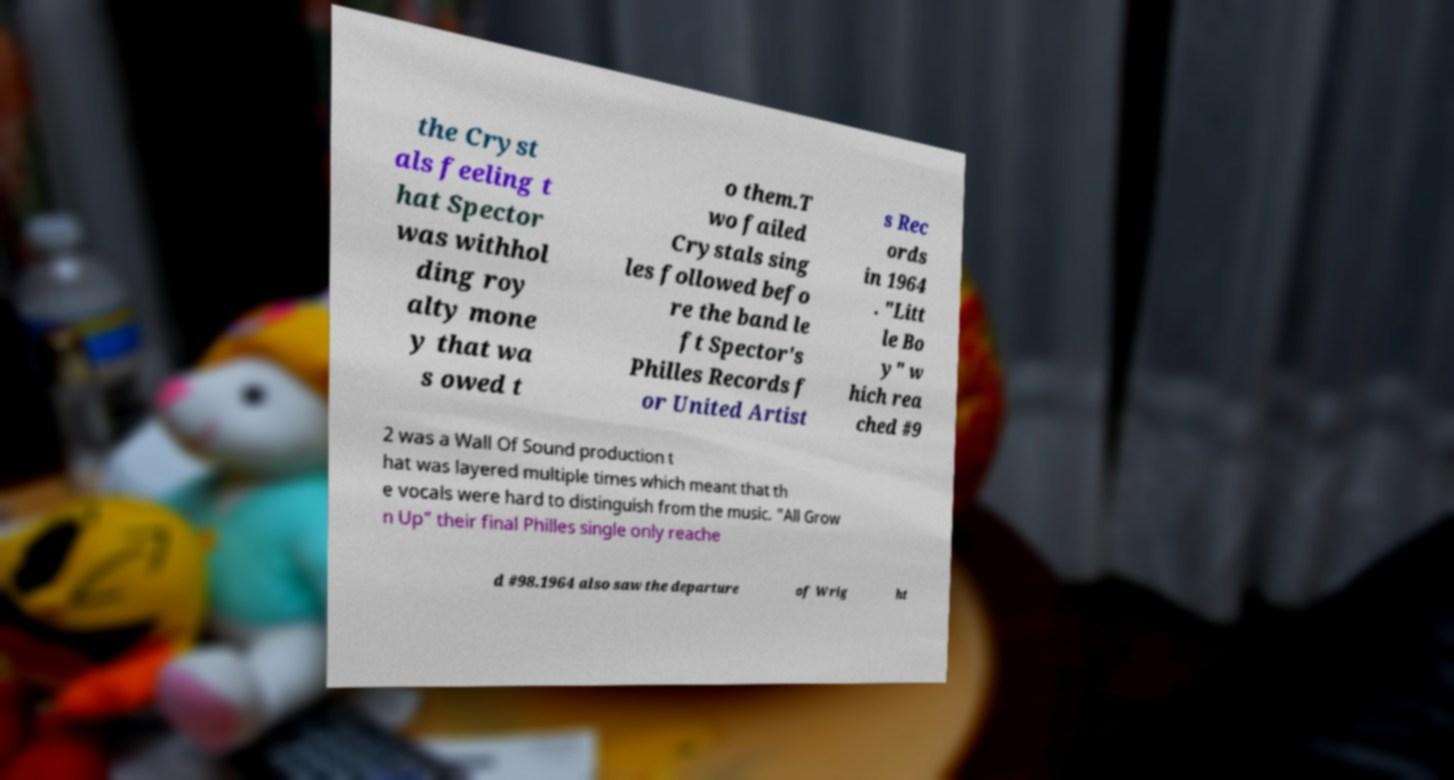Could you extract and type out the text from this image? the Cryst als feeling t hat Spector was withhol ding roy alty mone y that wa s owed t o them.T wo failed Crystals sing les followed befo re the band le ft Spector's Philles Records f or United Artist s Rec ords in 1964 . "Litt le Bo y" w hich rea ched #9 2 was a Wall Of Sound production t hat was layered multiple times which meant that th e vocals were hard to distinguish from the music. "All Grow n Up" their final Philles single only reache d #98.1964 also saw the departure of Wrig ht 